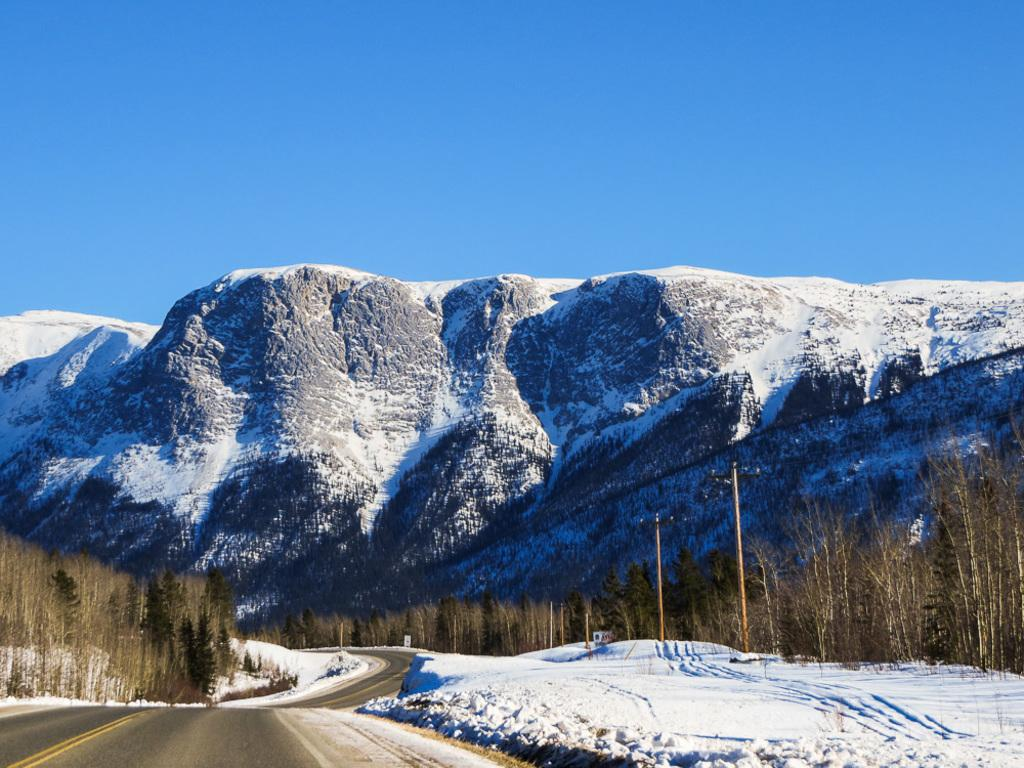What is the main subject of the image? The main subject of the image is a group of poles. What other natural elements can be seen in the image? There are trees and mountains visible in the image. Is there any man-made structure present in the image? Yes, there is a pathway in the image. What is visible in the background of the image? The sky is visible in the image. Can you tell me how many hydrants are present in the image? There are no hydrants visible in the image. What type of sail can be seen attached to the poles in the image? There is no sail present in the image; it features a group of poles, trees, a pathway, mountains, and the sky. 